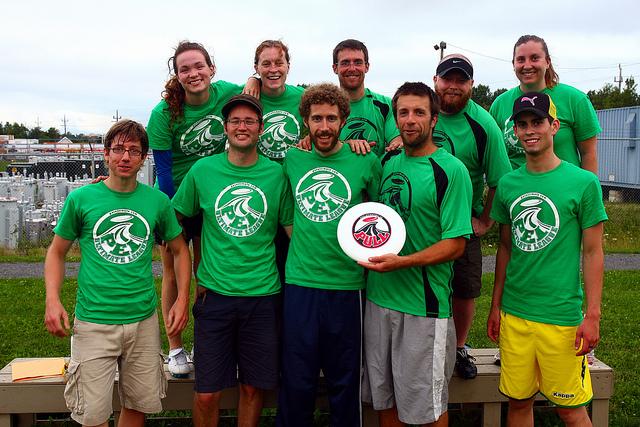Are they protesting something?
Quick response, please. No. What color is the shirts?
Concise answer only. Green. Which team is this?
Concise answer only. Ultimate league. 